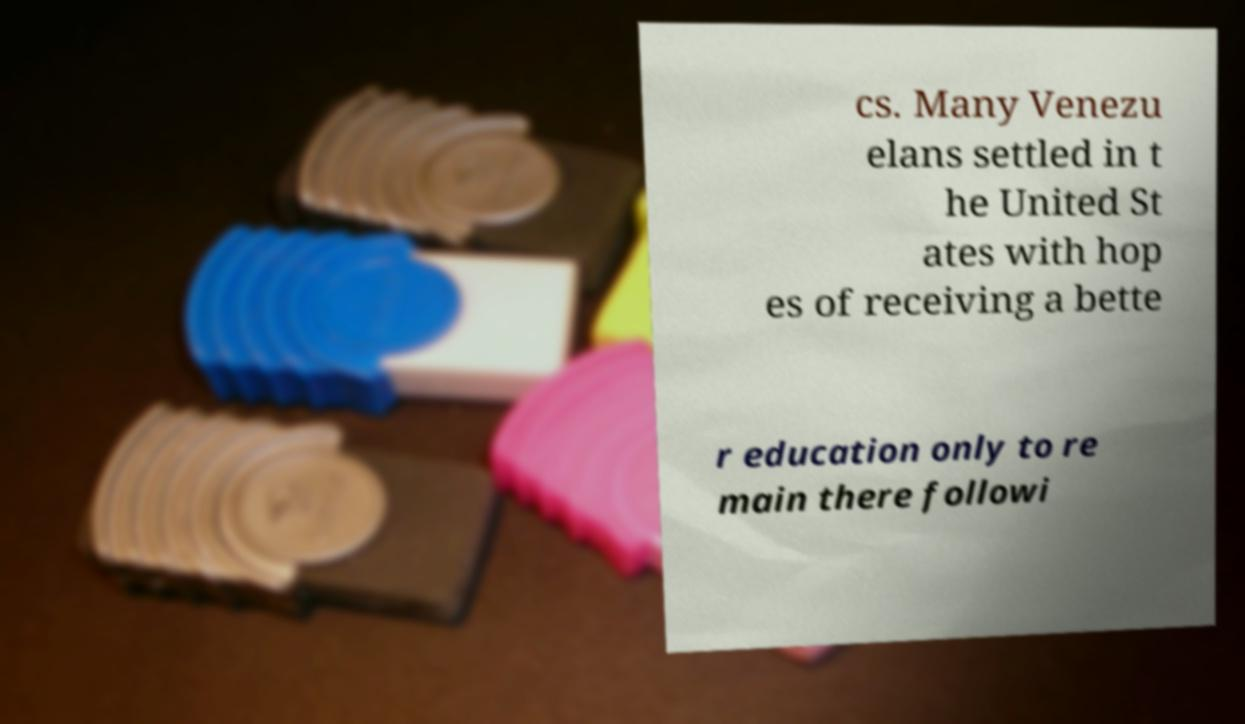There's text embedded in this image that I need extracted. Can you transcribe it verbatim? cs. Many Venezu elans settled in t he United St ates with hop es of receiving a bette r education only to re main there followi 